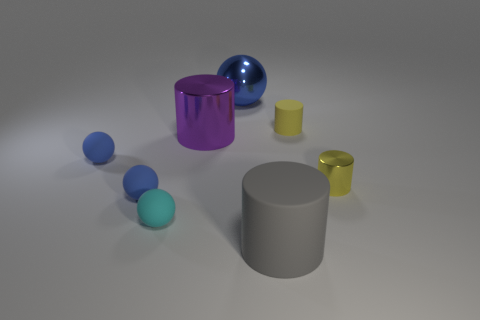What textures are visible on the objects in the image? The objects in the image display a variety of textures. The spheres and cylinders appear to have smooth surfaces, with varying degrees of shininess. The contrast between the reflective properties of the objects provides a rich study in texture, with some objects looking almost velvety matte and others having a clear specular highlight, suggesting a glossy finish. 